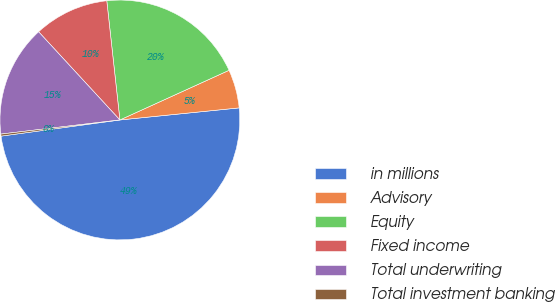Convert chart. <chart><loc_0><loc_0><loc_500><loc_500><pie_chart><fcel>in millions<fcel>Advisory<fcel>Equity<fcel>Fixed income<fcel>Total underwriting<fcel>Total investment banking<nl><fcel>49.46%<fcel>5.19%<fcel>19.95%<fcel>10.11%<fcel>15.03%<fcel>0.27%<nl></chart> 